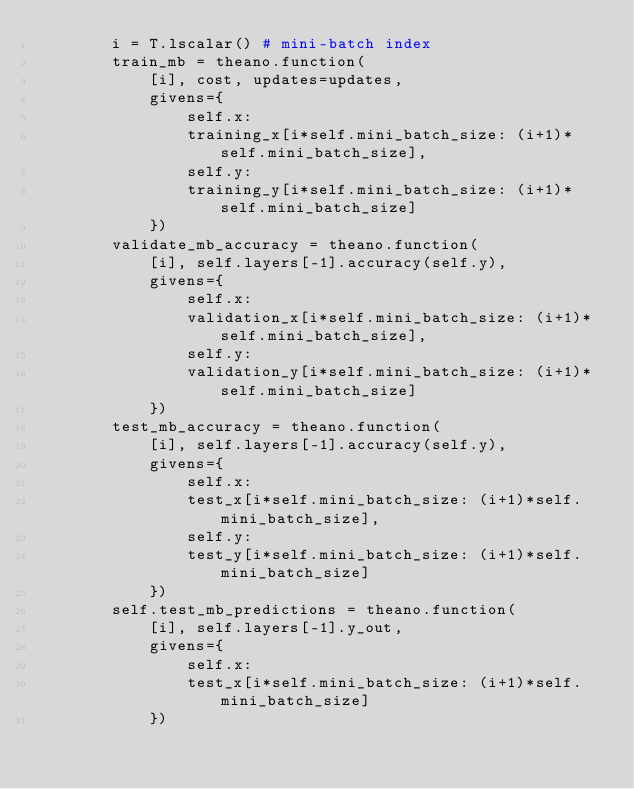<code> <loc_0><loc_0><loc_500><loc_500><_Python_>        i = T.lscalar() # mini-batch index
        train_mb = theano.function(
            [i], cost, updates=updates,
            givens={
                self.x:
                training_x[i*self.mini_batch_size: (i+1)*self.mini_batch_size],
                self.y:
                training_y[i*self.mini_batch_size: (i+1)*self.mini_batch_size]
            })
        validate_mb_accuracy = theano.function(
            [i], self.layers[-1].accuracy(self.y),
            givens={
                self.x:
                validation_x[i*self.mini_batch_size: (i+1)*self.mini_batch_size],
                self.y:
                validation_y[i*self.mini_batch_size: (i+1)*self.mini_batch_size]
            })
        test_mb_accuracy = theano.function(
            [i], self.layers[-1].accuracy(self.y),
            givens={
                self.x:
                test_x[i*self.mini_batch_size: (i+1)*self.mini_batch_size],
                self.y:
                test_y[i*self.mini_batch_size: (i+1)*self.mini_batch_size]
            })
        self.test_mb_predictions = theano.function(
            [i], self.layers[-1].y_out,
            givens={
                self.x:
                test_x[i*self.mini_batch_size: (i+1)*self.mini_batch_size]
            })</code> 